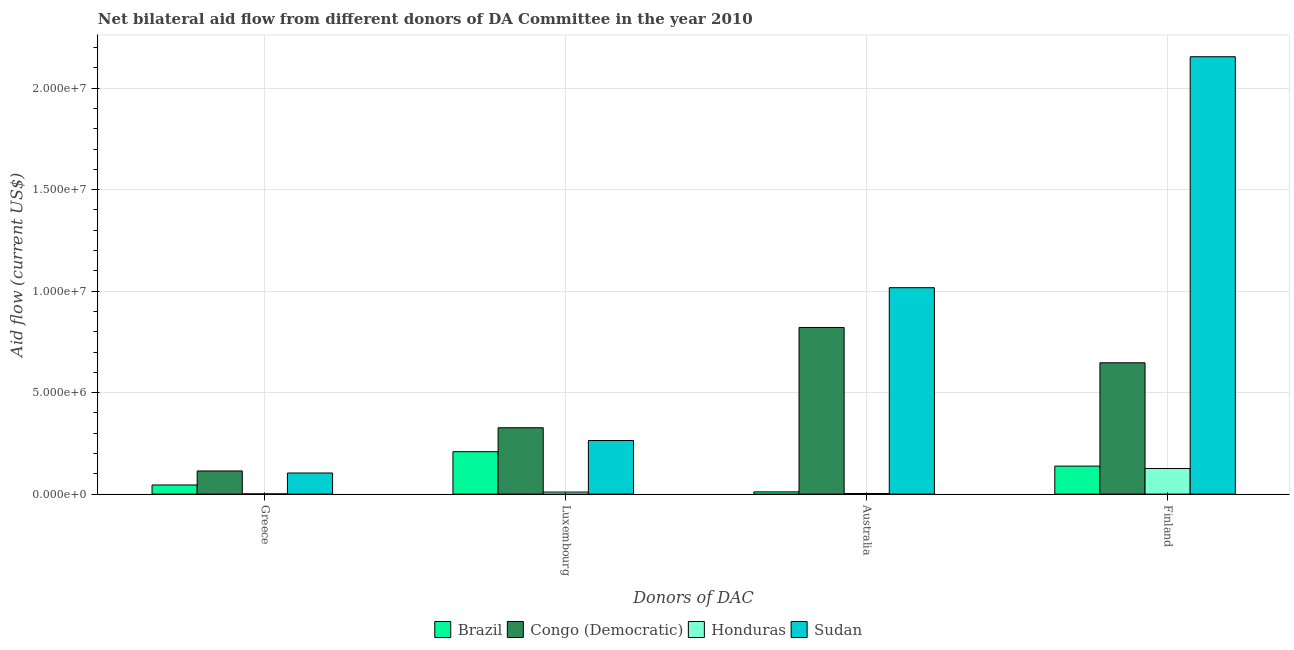How many groups of bars are there?
Offer a terse response. 4. Are the number of bars per tick equal to the number of legend labels?
Make the answer very short. Yes. Are the number of bars on each tick of the X-axis equal?
Keep it short and to the point. Yes. How many bars are there on the 1st tick from the right?
Offer a very short reply. 4. What is the label of the 2nd group of bars from the left?
Keep it short and to the point. Luxembourg. What is the amount of aid given by australia in Brazil?
Your response must be concise. 1.10e+05. Across all countries, what is the maximum amount of aid given by australia?
Your answer should be very brief. 1.02e+07. Across all countries, what is the minimum amount of aid given by finland?
Your response must be concise. 1.26e+06. In which country was the amount of aid given by finland maximum?
Make the answer very short. Sudan. In which country was the amount of aid given by australia minimum?
Ensure brevity in your answer.  Honduras. What is the total amount of aid given by finland in the graph?
Keep it short and to the point. 3.07e+07. What is the difference between the amount of aid given by greece in Congo (Democratic) and that in Brazil?
Keep it short and to the point. 6.90e+05. What is the difference between the amount of aid given by greece in Congo (Democratic) and the amount of aid given by finland in Honduras?
Ensure brevity in your answer.  -1.20e+05. What is the average amount of aid given by luxembourg per country?
Your response must be concise. 2.02e+06. What is the difference between the amount of aid given by australia and amount of aid given by greece in Sudan?
Ensure brevity in your answer.  9.13e+06. In how many countries, is the amount of aid given by australia greater than 16000000 US$?
Your answer should be very brief. 0. What is the ratio of the amount of aid given by luxembourg in Sudan to that in Congo (Democratic)?
Your answer should be very brief. 0.81. Is the difference between the amount of aid given by australia in Brazil and Sudan greater than the difference between the amount of aid given by luxembourg in Brazil and Sudan?
Make the answer very short. No. What is the difference between the highest and the second highest amount of aid given by luxembourg?
Ensure brevity in your answer.  6.30e+05. What is the difference between the highest and the lowest amount of aid given by australia?
Offer a terse response. 1.01e+07. In how many countries, is the amount of aid given by luxembourg greater than the average amount of aid given by luxembourg taken over all countries?
Your response must be concise. 3. Is it the case that in every country, the sum of the amount of aid given by luxembourg and amount of aid given by finland is greater than the sum of amount of aid given by greece and amount of aid given by australia?
Provide a succinct answer. No. What does the 1st bar from the left in Australia represents?
Offer a very short reply. Brazil. What does the 1st bar from the right in Finland represents?
Give a very brief answer. Sudan. Is it the case that in every country, the sum of the amount of aid given by greece and amount of aid given by luxembourg is greater than the amount of aid given by australia?
Your answer should be very brief. No. What is the difference between two consecutive major ticks on the Y-axis?
Your response must be concise. 5.00e+06. Are the values on the major ticks of Y-axis written in scientific E-notation?
Make the answer very short. Yes. Where does the legend appear in the graph?
Your answer should be very brief. Bottom center. What is the title of the graph?
Your answer should be compact. Net bilateral aid flow from different donors of DA Committee in the year 2010. What is the label or title of the X-axis?
Offer a very short reply. Donors of DAC. What is the label or title of the Y-axis?
Ensure brevity in your answer.  Aid flow (current US$). What is the Aid flow (current US$) in Brazil in Greece?
Provide a succinct answer. 4.50e+05. What is the Aid flow (current US$) of Congo (Democratic) in Greece?
Give a very brief answer. 1.14e+06. What is the Aid flow (current US$) in Honduras in Greece?
Your response must be concise. 10000. What is the Aid flow (current US$) in Sudan in Greece?
Offer a terse response. 1.04e+06. What is the Aid flow (current US$) in Brazil in Luxembourg?
Ensure brevity in your answer.  2.09e+06. What is the Aid flow (current US$) in Congo (Democratic) in Luxembourg?
Keep it short and to the point. 3.27e+06. What is the Aid flow (current US$) in Sudan in Luxembourg?
Make the answer very short. 2.64e+06. What is the Aid flow (current US$) in Congo (Democratic) in Australia?
Keep it short and to the point. 8.21e+06. What is the Aid flow (current US$) in Sudan in Australia?
Give a very brief answer. 1.02e+07. What is the Aid flow (current US$) of Brazil in Finland?
Your answer should be compact. 1.38e+06. What is the Aid flow (current US$) of Congo (Democratic) in Finland?
Ensure brevity in your answer.  6.47e+06. What is the Aid flow (current US$) in Honduras in Finland?
Give a very brief answer. 1.26e+06. What is the Aid flow (current US$) in Sudan in Finland?
Keep it short and to the point. 2.16e+07. Across all Donors of DAC, what is the maximum Aid flow (current US$) of Brazil?
Your answer should be very brief. 2.09e+06. Across all Donors of DAC, what is the maximum Aid flow (current US$) in Congo (Democratic)?
Your answer should be compact. 8.21e+06. Across all Donors of DAC, what is the maximum Aid flow (current US$) in Honduras?
Ensure brevity in your answer.  1.26e+06. Across all Donors of DAC, what is the maximum Aid flow (current US$) in Sudan?
Ensure brevity in your answer.  2.16e+07. Across all Donors of DAC, what is the minimum Aid flow (current US$) of Brazil?
Provide a succinct answer. 1.10e+05. Across all Donors of DAC, what is the minimum Aid flow (current US$) of Congo (Democratic)?
Provide a succinct answer. 1.14e+06. Across all Donors of DAC, what is the minimum Aid flow (current US$) in Honduras?
Offer a terse response. 10000. Across all Donors of DAC, what is the minimum Aid flow (current US$) in Sudan?
Offer a terse response. 1.04e+06. What is the total Aid flow (current US$) in Brazil in the graph?
Offer a terse response. 4.03e+06. What is the total Aid flow (current US$) of Congo (Democratic) in the graph?
Your answer should be compact. 1.91e+07. What is the total Aid flow (current US$) of Honduras in the graph?
Give a very brief answer. 1.40e+06. What is the total Aid flow (current US$) of Sudan in the graph?
Your response must be concise. 3.54e+07. What is the difference between the Aid flow (current US$) in Brazil in Greece and that in Luxembourg?
Provide a succinct answer. -1.64e+06. What is the difference between the Aid flow (current US$) in Congo (Democratic) in Greece and that in Luxembourg?
Ensure brevity in your answer.  -2.13e+06. What is the difference between the Aid flow (current US$) of Honduras in Greece and that in Luxembourg?
Give a very brief answer. -9.00e+04. What is the difference between the Aid flow (current US$) in Sudan in Greece and that in Luxembourg?
Your answer should be very brief. -1.60e+06. What is the difference between the Aid flow (current US$) of Brazil in Greece and that in Australia?
Your answer should be very brief. 3.40e+05. What is the difference between the Aid flow (current US$) of Congo (Democratic) in Greece and that in Australia?
Your answer should be very brief. -7.07e+06. What is the difference between the Aid flow (current US$) of Honduras in Greece and that in Australia?
Make the answer very short. -2.00e+04. What is the difference between the Aid flow (current US$) of Sudan in Greece and that in Australia?
Provide a succinct answer. -9.13e+06. What is the difference between the Aid flow (current US$) of Brazil in Greece and that in Finland?
Ensure brevity in your answer.  -9.30e+05. What is the difference between the Aid flow (current US$) of Congo (Democratic) in Greece and that in Finland?
Your answer should be very brief. -5.33e+06. What is the difference between the Aid flow (current US$) of Honduras in Greece and that in Finland?
Offer a terse response. -1.25e+06. What is the difference between the Aid flow (current US$) in Sudan in Greece and that in Finland?
Ensure brevity in your answer.  -2.05e+07. What is the difference between the Aid flow (current US$) of Brazil in Luxembourg and that in Australia?
Your answer should be compact. 1.98e+06. What is the difference between the Aid flow (current US$) in Congo (Democratic) in Luxembourg and that in Australia?
Ensure brevity in your answer.  -4.94e+06. What is the difference between the Aid flow (current US$) of Sudan in Luxembourg and that in Australia?
Provide a short and direct response. -7.53e+06. What is the difference between the Aid flow (current US$) in Brazil in Luxembourg and that in Finland?
Keep it short and to the point. 7.10e+05. What is the difference between the Aid flow (current US$) in Congo (Democratic) in Luxembourg and that in Finland?
Make the answer very short. -3.20e+06. What is the difference between the Aid flow (current US$) in Honduras in Luxembourg and that in Finland?
Your answer should be compact. -1.16e+06. What is the difference between the Aid flow (current US$) in Sudan in Luxembourg and that in Finland?
Give a very brief answer. -1.89e+07. What is the difference between the Aid flow (current US$) in Brazil in Australia and that in Finland?
Provide a succinct answer. -1.27e+06. What is the difference between the Aid flow (current US$) of Congo (Democratic) in Australia and that in Finland?
Give a very brief answer. 1.74e+06. What is the difference between the Aid flow (current US$) in Honduras in Australia and that in Finland?
Offer a terse response. -1.23e+06. What is the difference between the Aid flow (current US$) of Sudan in Australia and that in Finland?
Your answer should be compact. -1.14e+07. What is the difference between the Aid flow (current US$) of Brazil in Greece and the Aid flow (current US$) of Congo (Democratic) in Luxembourg?
Offer a terse response. -2.82e+06. What is the difference between the Aid flow (current US$) in Brazil in Greece and the Aid flow (current US$) in Sudan in Luxembourg?
Your answer should be compact. -2.19e+06. What is the difference between the Aid flow (current US$) of Congo (Democratic) in Greece and the Aid flow (current US$) of Honduras in Luxembourg?
Give a very brief answer. 1.04e+06. What is the difference between the Aid flow (current US$) in Congo (Democratic) in Greece and the Aid flow (current US$) in Sudan in Luxembourg?
Make the answer very short. -1.50e+06. What is the difference between the Aid flow (current US$) in Honduras in Greece and the Aid flow (current US$) in Sudan in Luxembourg?
Provide a succinct answer. -2.63e+06. What is the difference between the Aid flow (current US$) of Brazil in Greece and the Aid flow (current US$) of Congo (Democratic) in Australia?
Your answer should be compact. -7.76e+06. What is the difference between the Aid flow (current US$) of Brazil in Greece and the Aid flow (current US$) of Honduras in Australia?
Ensure brevity in your answer.  4.20e+05. What is the difference between the Aid flow (current US$) in Brazil in Greece and the Aid flow (current US$) in Sudan in Australia?
Give a very brief answer. -9.72e+06. What is the difference between the Aid flow (current US$) in Congo (Democratic) in Greece and the Aid flow (current US$) in Honduras in Australia?
Make the answer very short. 1.11e+06. What is the difference between the Aid flow (current US$) of Congo (Democratic) in Greece and the Aid flow (current US$) of Sudan in Australia?
Your answer should be very brief. -9.03e+06. What is the difference between the Aid flow (current US$) of Honduras in Greece and the Aid flow (current US$) of Sudan in Australia?
Offer a very short reply. -1.02e+07. What is the difference between the Aid flow (current US$) in Brazil in Greece and the Aid flow (current US$) in Congo (Democratic) in Finland?
Your answer should be compact. -6.02e+06. What is the difference between the Aid flow (current US$) in Brazil in Greece and the Aid flow (current US$) in Honduras in Finland?
Your answer should be very brief. -8.10e+05. What is the difference between the Aid flow (current US$) in Brazil in Greece and the Aid flow (current US$) in Sudan in Finland?
Ensure brevity in your answer.  -2.11e+07. What is the difference between the Aid flow (current US$) in Congo (Democratic) in Greece and the Aid flow (current US$) in Sudan in Finland?
Provide a short and direct response. -2.04e+07. What is the difference between the Aid flow (current US$) in Honduras in Greece and the Aid flow (current US$) in Sudan in Finland?
Provide a short and direct response. -2.15e+07. What is the difference between the Aid flow (current US$) of Brazil in Luxembourg and the Aid flow (current US$) of Congo (Democratic) in Australia?
Your answer should be very brief. -6.12e+06. What is the difference between the Aid flow (current US$) in Brazil in Luxembourg and the Aid flow (current US$) in Honduras in Australia?
Provide a succinct answer. 2.06e+06. What is the difference between the Aid flow (current US$) of Brazil in Luxembourg and the Aid flow (current US$) of Sudan in Australia?
Offer a very short reply. -8.08e+06. What is the difference between the Aid flow (current US$) of Congo (Democratic) in Luxembourg and the Aid flow (current US$) of Honduras in Australia?
Ensure brevity in your answer.  3.24e+06. What is the difference between the Aid flow (current US$) in Congo (Democratic) in Luxembourg and the Aid flow (current US$) in Sudan in Australia?
Your response must be concise. -6.90e+06. What is the difference between the Aid flow (current US$) of Honduras in Luxembourg and the Aid flow (current US$) of Sudan in Australia?
Make the answer very short. -1.01e+07. What is the difference between the Aid flow (current US$) in Brazil in Luxembourg and the Aid flow (current US$) in Congo (Democratic) in Finland?
Your response must be concise. -4.38e+06. What is the difference between the Aid flow (current US$) in Brazil in Luxembourg and the Aid flow (current US$) in Honduras in Finland?
Offer a very short reply. 8.30e+05. What is the difference between the Aid flow (current US$) in Brazil in Luxembourg and the Aid flow (current US$) in Sudan in Finland?
Offer a very short reply. -1.95e+07. What is the difference between the Aid flow (current US$) in Congo (Democratic) in Luxembourg and the Aid flow (current US$) in Honduras in Finland?
Provide a succinct answer. 2.01e+06. What is the difference between the Aid flow (current US$) of Congo (Democratic) in Luxembourg and the Aid flow (current US$) of Sudan in Finland?
Provide a succinct answer. -1.83e+07. What is the difference between the Aid flow (current US$) in Honduras in Luxembourg and the Aid flow (current US$) in Sudan in Finland?
Offer a terse response. -2.14e+07. What is the difference between the Aid flow (current US$) of Brazil in Australia and the Aid flow (current US$) of Congo (Democratic) in Finland?
Your answer should be compact. -6.36e+06. What is the difference between the Aid flow (current US$) of Brazil in Australia and the Aid flow (current US$) of Honduras in Finland?
Your answer should be very brief. -1.15e+06. What is the difference between the Aid flow (current US$) of Brazil in Australia and the Aid flow (current US$) of Sudan in Finland?
Keep it short and to the point. -2.14e+07. What is the difference between the Aid flow (current US$) of Congo (Democratic) in Australia and the Aid flow (current US$) of Honduras in Finland?
Give a very brief answer. 6.95e+06. What is the difference between the Aid flow (current US$) in Congo (Democratic) in Australia and the Aid flow (current US$) in Sudan in Finland?
Your response must be concise. -1.33e+07. What is the difference between the Aid flow (current US$) of Honduras in Australia and the Aid flow (current US$) of Sudan in Finland?
Give a very brief answer. -2.15e+07. What is the average Aid flow (current US$) in Brazil per Donors of DAC?
Make the answer very short. 1.01e+06. What is the average Aid flow (current US$) of Congo (Democratic) per Donors of DAC?
Make the answer very short. 4.77e+06. What is the average Aid flow (current US$) of Honduras per Donors of DAC?
Your answer should be very brief. 3.50e+05. What is the average Aid flow (current US$) of Sudan per Donors of DAC?
Your response must be concise. 8.85e+06. What is the difference between the Aid flow (current US$) of Brazil and Aid flow (current US$) of Congo (Democratic) in Greece?
Provide a short and direct response. -6.90e+05. What is the difference between the Aid flow (current US$) of Brazil and Aid flow (current US$) of Sudan in Greece?
Offer a very short reply. -5.90e+05. What is the difference between the Aid flow (current US$) of Congo (Democratic) and Aid flow (current US$) of Honduras in Greece?
Your response must be concise. 1.13e+06. What is the difference between the Aid flow (current US$) of Congo (Democratic) and Aid flow (current US$) of Sudan in Greece?
Give a very brief answer. 1.00e+05. What is the difference between the Aid flow (current US$) of Honduras and Aid flow (current US$) of Sudan in Greece?
Keep it short and to the point. -1.03e+06. What is the difference between the Aid flow (current US$) of Brazil and Aid flow (current US$) of Congo (Democratic) in Luxembourg?
Give a very brief answer. -1.18e+06. What is the difference between the Aid flow (current US$) of Brazil and Aid flow (current US$) of Honduras in Luxembourg?
Your answer should be very brief. 1.99e+06. What is the difference between the Aid flow (current US$) of Brazil and Aid flow (current US$) of Sudan in Luxembourg?
Offer a terse response. -5.50e+05. What is the difference between the Aid flow (current US$) in Congo (Democratic) and Aid flow (current US$) in Honduras in Luxembourg?
Provide a succinct answer. 3.17e+06. What is the difference between the Aid flow (current US$) of Congo (Democratic) and Aid flow (current US$) of Sudan in Luxembourg?
Offer a very short reply. 6.30e+05. What is the difference between the Aid flow (current US$) of Honduras and Aid flow (current US$) of Sudan in Luxembourg?
Your answer should be very brief. -2.54e+06. What is the difference between the Aid flow (current US$) in Brazil and Aid flow (current US$) in Congo (Democratic) in Australia?
Keep it short and to the point. -8.10e+06. What is the difference between the Aid flow (current US$) in Brazil and Aid flow (current US$) in Honduras in Australia?
Your answer should be compact. 8.00e+04. What is the difference between the Aid flow (current US$) of Brazil and Aid flow (current US$) of Sudan in Australia?
Provide a short and direct response. -1.01e+07. What is the difference between the Aid flow (current US$) of Congo (Democratic) and Aid flow (current US$) of Honduras in Australia?
Offer a terse response. 8.18e+06. What is the difference between the Aid flow (current US$) of Congo (Democratic) and Aid flow (current US$) of Sudan in Australia?
Keep it short and to the point. -1.96e+06. What is the difference between the Aid flow (current US$) in Honduras and Aid flow (current US$) in Sudan in Australia?
Your answer should be very brief. -1.01e+07. What is the difference between the Aid flow (current US$) in Brazil and Aid flow (current US$) in Congo (Democratic) in Finland?
Provide a short and direct response. -5.09e+06. What is the difference between the Aid flow (current US$) in Brazil and Aid flow (current US$) in Sudan in Finland?
Provide a succinct answer. -2.02e+07. What is the difference between the Aid flow (current US$) of Congo (Democratic) and Aid flow (current US$) of Honduras in Finland?
Your response must be concise. 5.21e+06. What is the difference between the Aid flow (current US$) of Congo (Democratic) and Aid flow (current US$) of Sudan in Finland?
Ensure brevity in your answer.  -1.51e+07. What is the difference between the Aid flow (current US$) of Honduras and Aid flow (current US$) of Sudan in Finland?
Ensure brevity in your answer.  -2.03e+07. What is the ratio of the Aid flow (current US$) of Brazil in Greece to that in Luxembourg?
Keep it short and to the point. 0.22. What is the ratio of the Aid flow (current US$) of Congo (Democratic) in Greece to that in Luxembourg?
Keep it short and to the point. 0.35. What is the ratio of the Aid flow (current US$) of Honduras in Greece to that in Luxembourg?
Make the answer very short. 0.1. What is the ratio of the Aid flow (current US$) of Sudan in Greece to that in Luxembourg?
Offer a terse response. 0.39. What is the ratio of the Aid flow (current US$) in Brazil in Greece to that in Australia?
Keep it short and to the point. 4.09. What is the ratio of the Aid flow (current US$) in Congo (Democratic) in Greece to that in Australia?
Offer a very short reply. 0.14. What is the ratio of the Aid flow (current US$) in Sudan in Greece to that in Australia?
Keep it short and to the point. 0.1. What is the ratio of the Aid flow (current US$) of Brazil in Greece to that in Finland?
Ensure brevity in your answer.  0.33. What is the ratio of the Aid flow (current US$) of Congo (Democratic) in Greece to that in Finland?
Make the answer very short. 0.18. What is the ratio of the Aid flow (current US$) in Honduras in Greece to that in Finland?
Provide a short and direct response. 0.01. What is the ratio of the Aid flow (current US$) of Sudan in Greece to that in Finland?
Provide a succinct answer. 0.05. What is the ratio of the Aid flow (current US$) of Congo (Democratic) in Luxembourg to that in Australia?
Your answer should be compact. 0.4. What is the ratio of the Aid flow (current US$) of Sudan in Luxembourg to that in Australia?
Your answer should be very brief. 0.26. What is the ratio of the Aid flow (current US$) of Brazil in Luxembourg to that in Finland?
Offer a very short reply. 1.51. What is the ratio of the Aid flow (current US$) of Congo (Democratic) in Luxembourg to that in Finland?
Offer a very short reply. 0.51. What is the ratio of the Aid flow (current US$) of Honduras in Luxembourg to that in Finland?
Ensure brevity in your answer.  0.08. What is the ratio of the Aid flow (current US$) of Sudan in Luxembourg to that in Finland?
Provide a succinct answer. 0.12. What is the ratio of the Aid flow (current US$) of Brazil in Australia to that in Finland?
Ensure brevity in your answer.  0.08. What is the ratio of the Aid flow (current US$) in Congo (Democratic) in Australia to that in Finland?
Your response must be concise. 1.27. What is the ratio of the Aid flow (current US$) in Honduras in Australia to that in Finland?
Offer a terse response. 0.02. What is the ratio of the Aid flow (current US$) of Sudan in Australia to that in Finland?
Provide a short and direct response. 0.47. What is the difference between the highest and the second highest Aid flow (current US$) of Brazil?
Give a very brief answer. 7.10e+05. What is the difference between the highest and the second highest Aid flow (current US$) of Congo (Democratic)?
Your answer should be very brief. 1.74e+06. What is the difference between the highest and the second highest Aid flow (current US$) of Honduras?
Offer a very short reply. 1.16e+06. What is the difference between the highest and the second highest Aid flow (current US$) of Sudan?
Offer a very short reply. 1.14e+07. What is the difference between the highest and the lowest Aid flow (current US$) in Brazil?
Give a very brief answer. 1.98e+06. What is the difference between the highest and the lowest Aid flow (current US$) in Congo (Democratic)?
Make the answer very short. 7.07e+06. What is the difference between the highest and the lowest Aid flow (current US$) in Honduras?
Offer a very short reply. 1.25e+06. What is the difference between the highest and the lowest Aid flow (current US$) in Sudan?
Make the answer very short. 2.05e+07. 